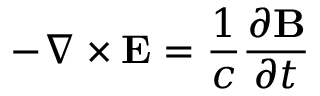Convert formula to latex. <formula><loc_0><loc_0><loc_500><loc_500>- \nabla \times E = { \frac { 1 } { c } } { \frac { \partial B } { \partial t } }</formula> 